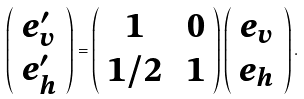<formula> <loc_0><loc_0><loc_500><loc_500>\left ( \begin{array} { c } e _ { v } ^ { \prime } \\ e _ { h } ^ { \prime } \end{array} \right ) = \left ( \begin{array} { c c } 1 & \ 0 \\ 1 / 2 & \ 1 \end{array} \right ) \left ( \begin{array} { c } e _ { v } \\ e _ { h } \end{array} \right ) .</formula> 